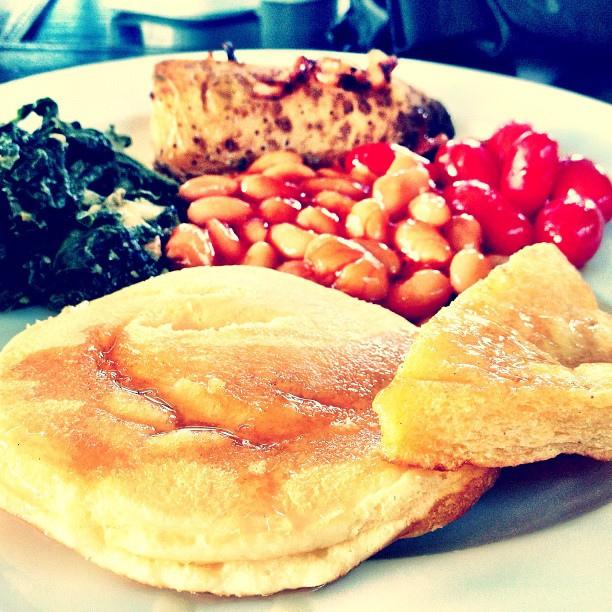Is there any vegetables on the plate?
Concise answer only. Yes. Is this dinner meal?
Be succinct. Yes. What color is the plate?
Write a very short answer. White. How many pancakes are cooking?
Short answer required. 0. 